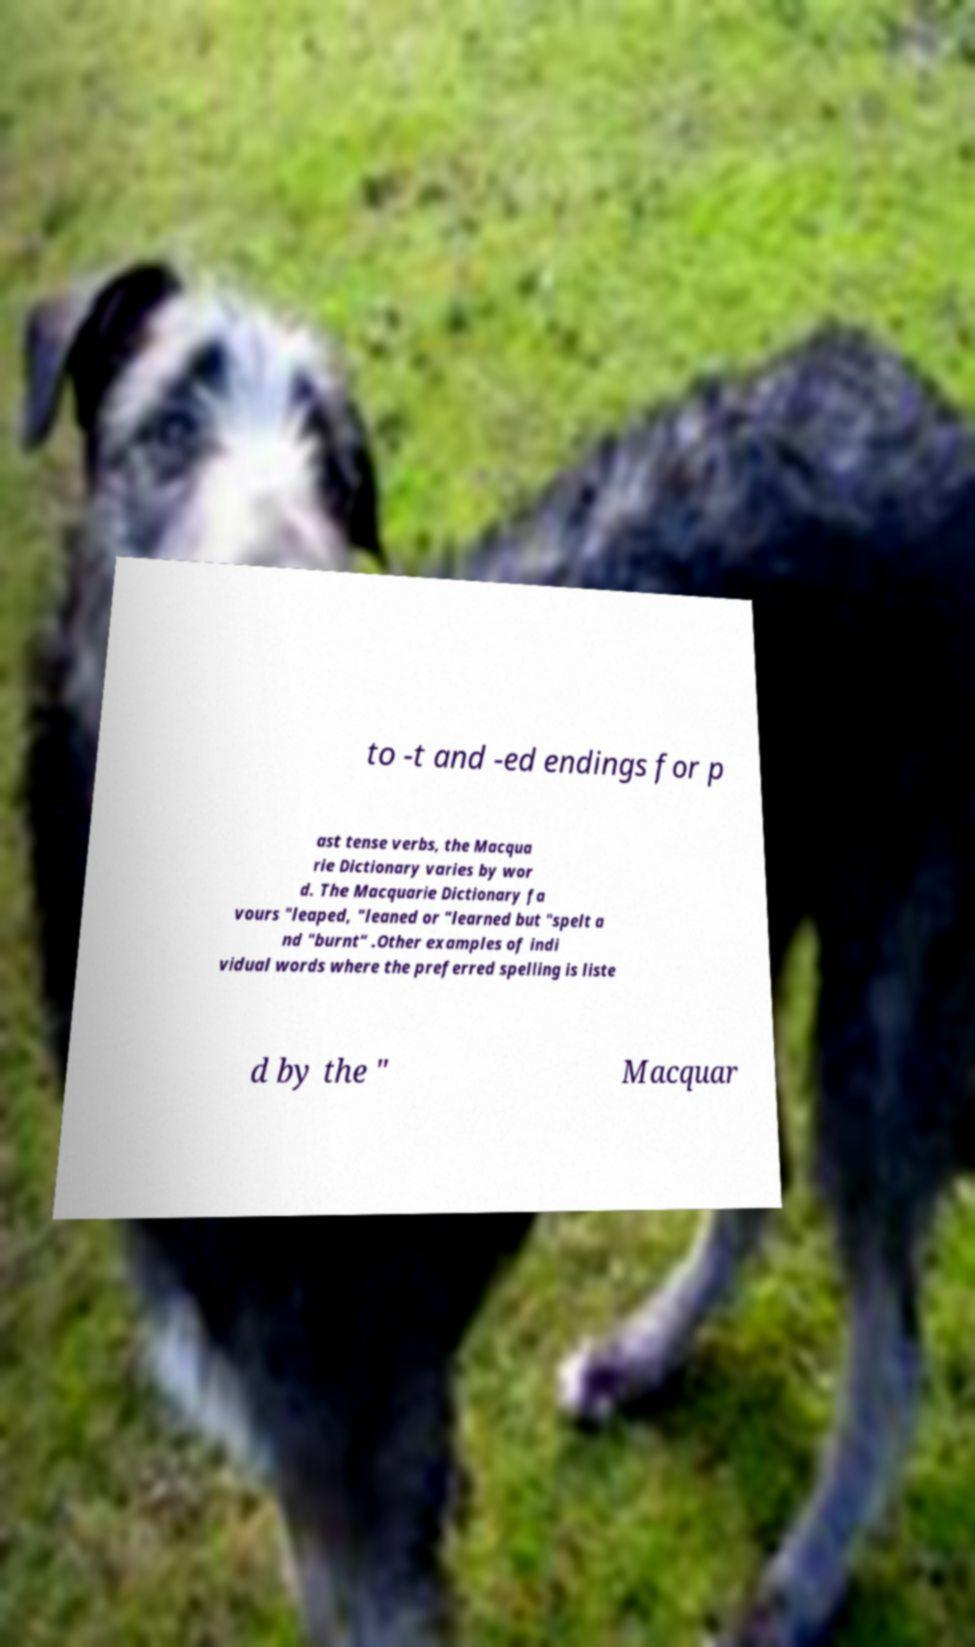Could you assist in decoding the text presented in this image and type it out clearly? to -t and -ed endings for p ast tense verbs, the Macqua rie Dictionary varies by wor d. The Macquarie Dictionary fa vours "leaped, "leaned or "learned but "spelt a nd "burnt" .Other examples of indi vidual words where the preferred spelling is liste d by the " Macquar 